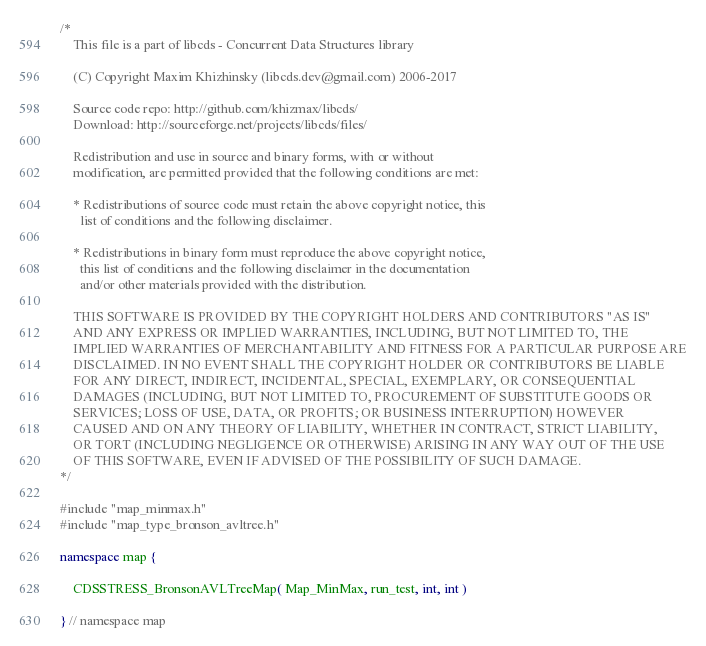Convert code to text. <code><loc_0><loc_0><loc_500><loc_500><_C++_>/*
    This file is a part of libcds - Concurrent Data Structures library

    (C) Copyright Maxim Khizhinsky (libcds.dev@gmail.com) 2006-2017

    Source code repo: http://github.com/khizmax/libcds/
    Download: http://sourceforge.net/projects/libcds/files/

    Redistribution and use in source and binary forms, with or without
    modification, are permitted provided that the following conditions are met:

    * Redistributions of source code must retain the above copyright notice, this
      list of conditions and the following disclaimer.

    * Redistributions in binary form must reproduce the above copyright notice,
      this list of conditions and the following disclaimer in the documentation
      and/or other materials provided with the distribution.

    THIS SOFTWARE IS PROVIDED BY THE COPYRIGHT HOLDERS AND CONTRIBUTORS "AS IS"
    AND ANY EXPRESS OR IMPLIED WARRANTIES, INCLUDING, BUT NOT LIMITED TO, THE
    IMPLIED WARRANTIES OF MERCHANTABILITY AND FITNESS FOR A PARTICULAR PURPOSE ARE
    DISCLAIMED. IN NO EVENT SHALL THE COPYRIGHT HOLDER OR CONTRIBUTORS BE LIABLE
    FOR ANY DIRECT, INDIRECT, INCIDENTAL, SPECIAL, EXEMPLARY, OR CONSEQUENTIAL
    DAMAGES (INCLUDING, BUT NOT LIMITED TO, PROCUREMENT OF SUBSTITUTE GOODS OR
    SERVICES; LOSS OF USE, DATA, OR PROFITS; OR BUSINESS INTERRUPTION) HOWEVER
    CAUSED AND ON ANY THEORY OF LIABILITY, WHETHER IN CONTRACT, STRICT LIABILITY,
    OR TORT (INCLUDING NEGLIGENCE OR OTHERWISE) ARISING IN ANY WAY OUT OF THE USE
    OF THIS SOFTWARE, EVEN IF ADVISED OF THE POSSIBILITY OF SUCH DAMAGE.
*/

#include "map_minmax.h"
#include "map_type_bronson_avltree.h"

namespace map {

    CDSSTRESS_BronsonAVLTreeMap( Map_MinMax, run_test, int, int )

} // namespace map
</code> 